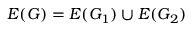Convert formula to latex. <formula><loc_0><loc_0><loc_500><loc_500>E ( G ) = E ( G _ { 1 } ) \cup E ( G _ { 2 } )</formula> 